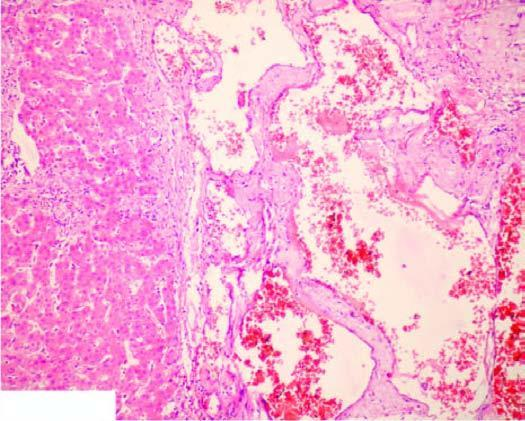what is seen between the cavernous spaces?
Answer the question using a single word or phrase. Scanty connective tissue stroma 